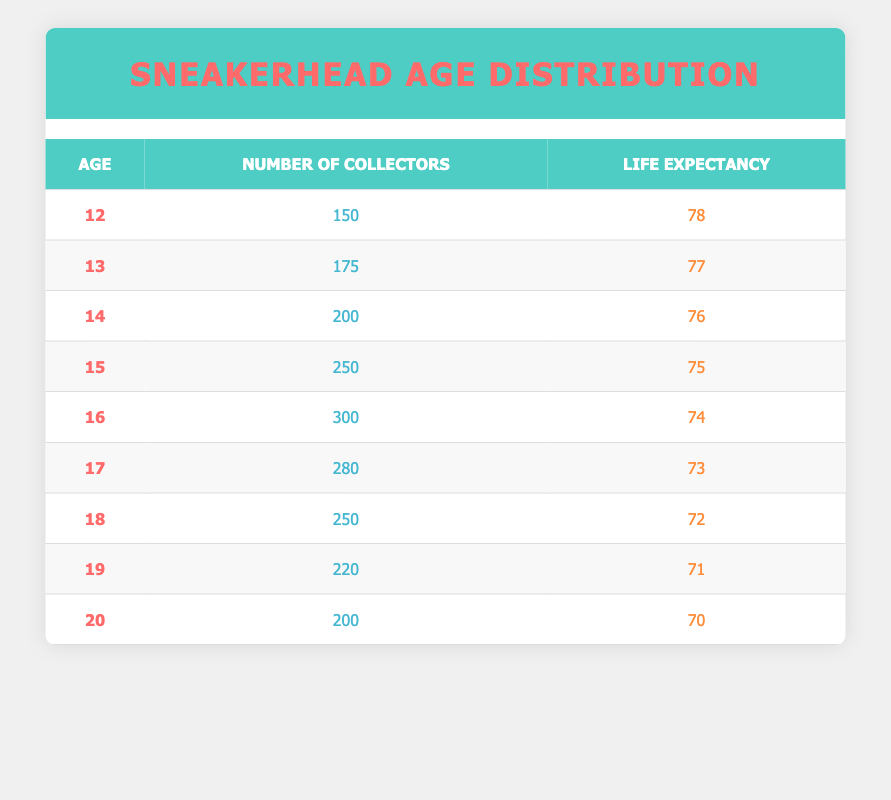What is the life expectancy of a 15-year-old sneaker collector? According to the table, the life expectancy of a 15-year-old is listed directly under that age. It shows a value of 75 years.
Answer: 75 How many collectors are aged 16? The table specifies the number of collectors for each age. For age 16, the number of collectors is noted as 300.
Answer: 300 What is the total number of sneaker collectors aged 12 to 15? To find the total, sum the number of collectors from ages 12, 13, 14, and 15: 150 (age 12) + 175 (age 13) + 200 (age 14) + 250 (age 15) = 775.
Answer: 775 Is there an age group with more than 250 collectors? By examining the table, it shows that both ages 16 (300) and 15 (250) have significant collector counts. However, only age 16 has more than 250, confirming that the statement is yes.
Answer: Yes What is the average life expectancy of sneaker collectors aged 17 to 20? First, sum the life expectancy values from ages 17 to 20: 73 (age 17) + 72 (age 18) + 71 (age 19) + 70 (age 20) = 286. Then, divide by the number of age groups, which is 4: 286 / 4 = 71.5.
Answer: 71.5 How many total collectors are there from age 12 to 19? The total number of collectors can be calculated by adding the columns for the various ages from 12 to 19: 150 (age 12) + 175 (age 13) + 200 (age 14) + 250 (age 15) + 300 (age 16) + 280 (age 17) + 250 (age 18) + 220 (age 19) = 1875.
Answer: 1875 Is the number of collectors higher at age 18 than at age 19? The table indicates that for age 18, there are 250 collectors and for age 19, there are 220 collectors. Thus, age 18 indeed has more collectors than age 19, confirming a yes answer.
Answer: Yes What is the difference in the number of collectors between ages 14 and 16? To find the difference, subtract the number of collectors at age 14 (200) from age 16 (300): 300 - 200 = 100. Therefore, the difference is 100 collectors.
Answer: 100 